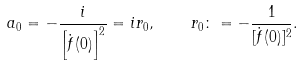<formula> <loc_0><loc_0><loc_500><loc_500>a _ { 0 } = - \frac { i } { \left [ \dot { f } ( 0 ) \right ] ^ { 2 } } = i r _ { 0 } , \quad r _ { 0 } \colon = - \frac { 1 } { [ \dot { f } ( 0 ) ] ^ { 2 } } .</formula> 